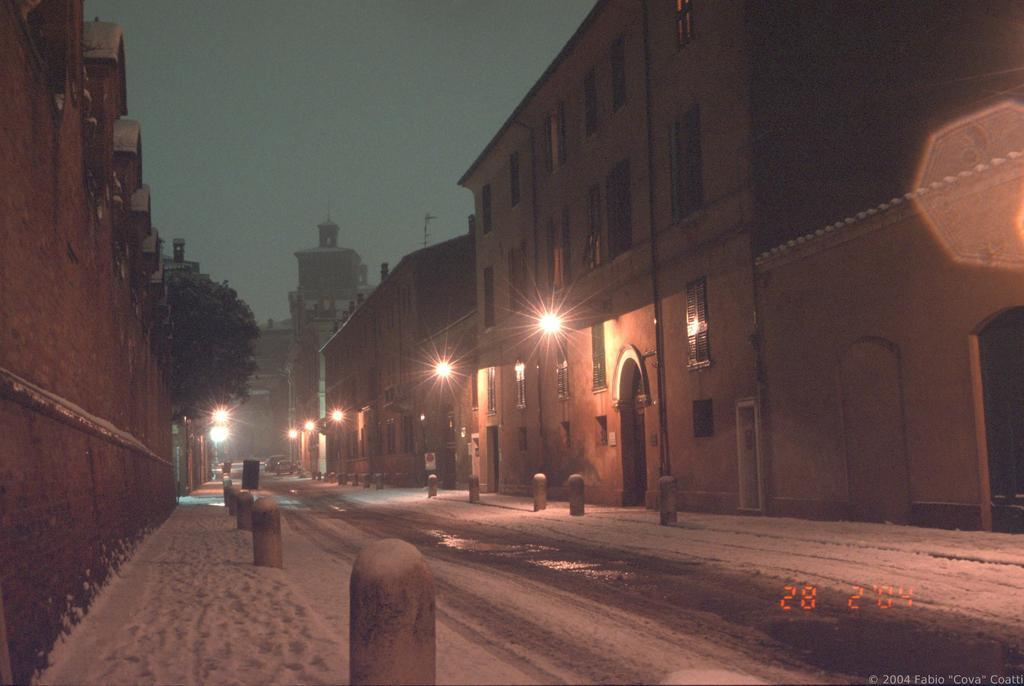What type of structures can be seen in the image? There are buildings in the image. What can be seen illuminated in the image? There are lights in the image. What architectural features are visible on the buildings? There are windows in the image. What vertical object is present in the image? There is a pole in the image. What type of plant is visible in the image? There is a tree in the image. What type of transportation is present in the image? There are vehicles in the image. What part of the natural environment is visible in the image? The sky is visible in the image. Can you see the aunt's lipstick in the image? There is no mention of an aunt or lipstick in the image, so it cannot be seen. 